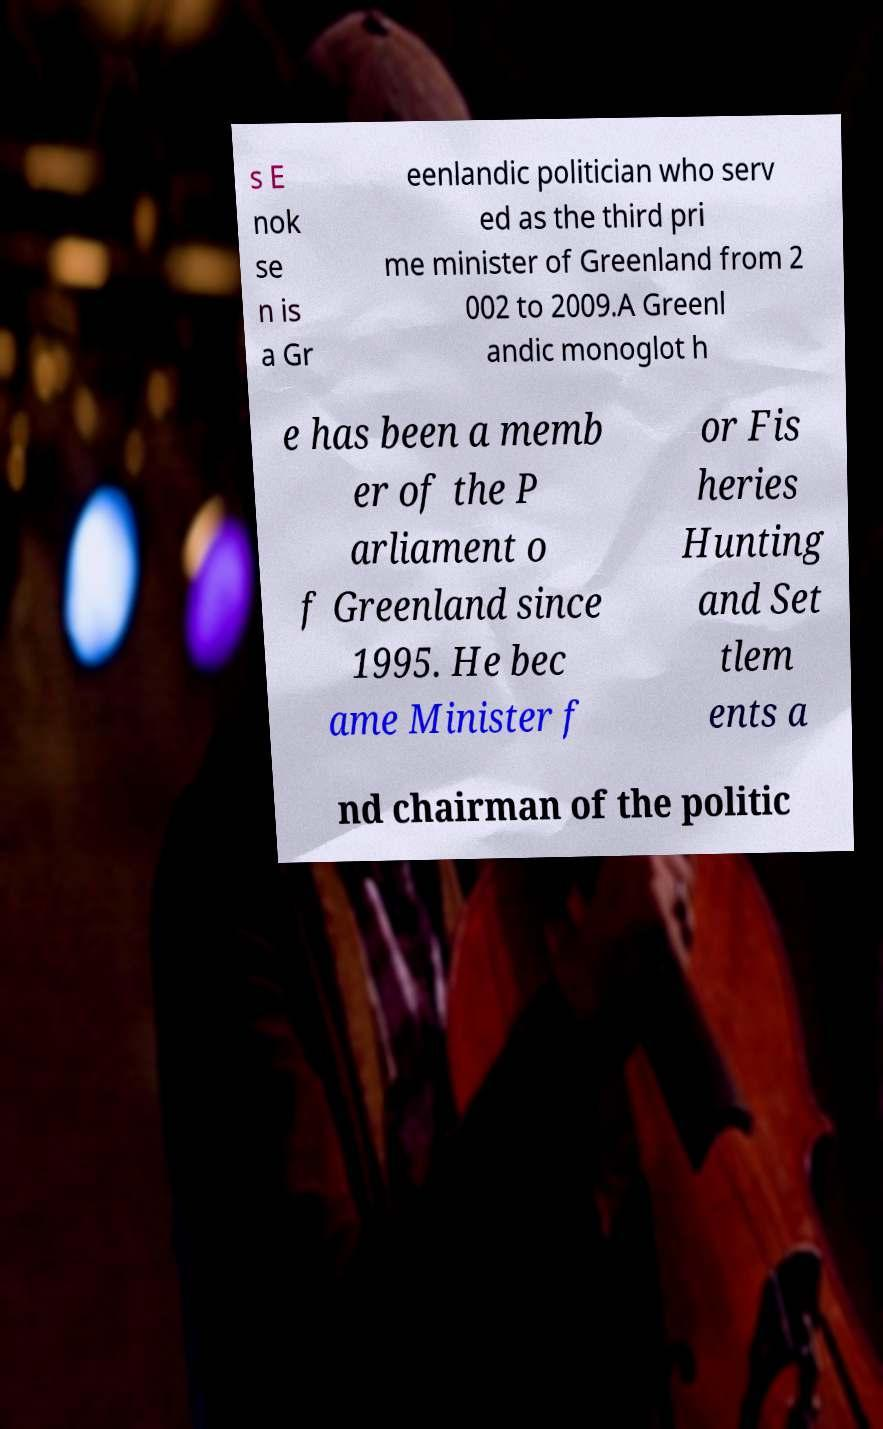Can you read and provide the text displayed in the image?This photo seems to have some interesting text. Can you extract and type it out for me? s E nok se n is a Gr eenlandic politician who serv ed as the third pri me minister of Greenland from 2 002 to 2009.A Greenl andic monoglot h e has been a memb er of the P arliament o f Greenland since 1995. He bec ame Minister f or Fis heries Hunting and Set tlem ents a nd chairman of the politic 